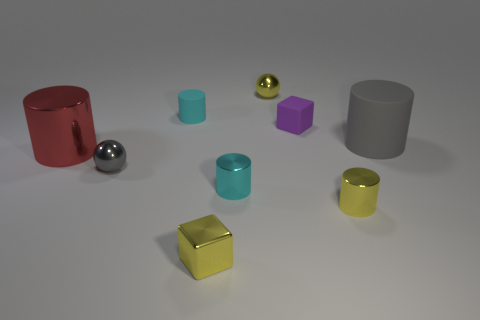Subtract all red cylinders. How many cylinders are left? 4 Subtract all yellow metallic cylinders. How many cylinders are left? 4 Subtract all purple cylinders. Subtract all blue balls. How many cylinders are left? 5 Add 1 yellow metallic objects. How many objects exist? 10 Subtract all cylinders. How many objects are left? 4 Subtract all tiny shiny spheres. Subtract all big red things. How many objects are left? 6 Add 1 red things. How many red things are left? 2 Add 5 big cylinders. How many big cylinders exist? 7 Subtract 0 red balls. How many objects are left? 9 